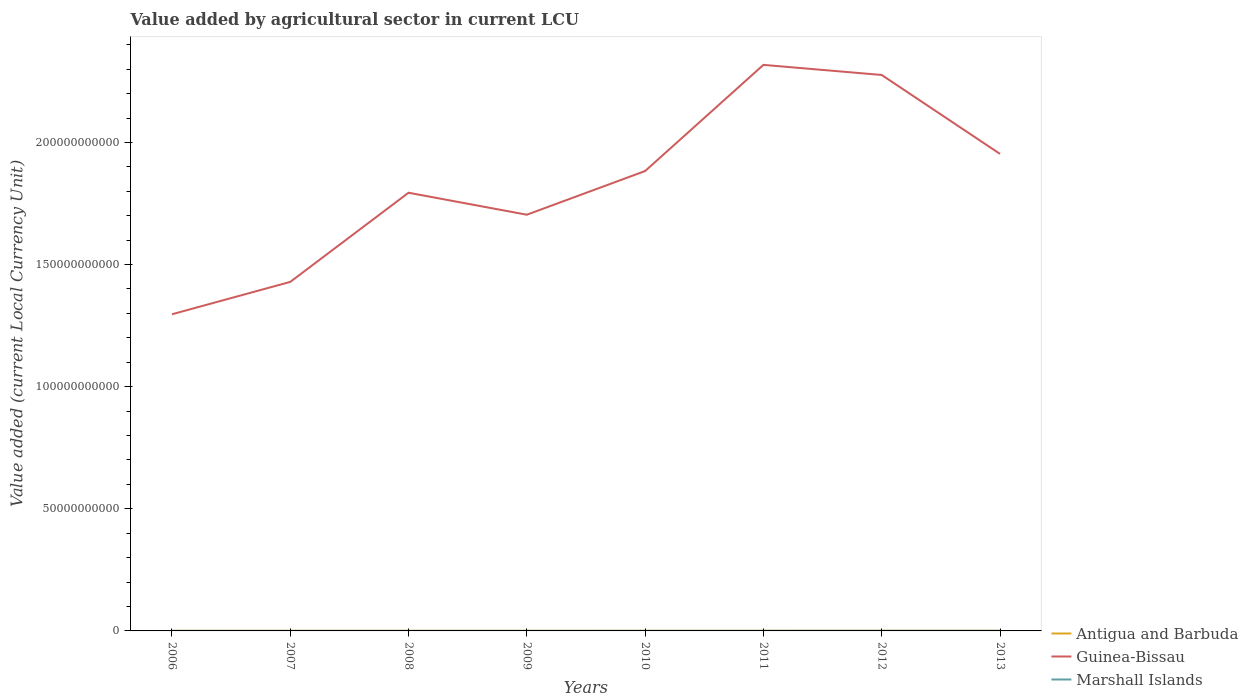Does the line corresponding to Guinea-Bissau intersect with the line corresponding to Marshall Islands?
Ensure brevity in your answer.  No. Is the number of lines equal to the number of legend labels?
Provide a short and direct response. Yes. Across all years, what is the maximum value added by agricultural sector in Antigua and Barbuda?
Your answer should be compact. 4.95e+07. In which year was the value added by agricultural sector in Antigua and Barbuda maximum?
Offer a very short reply. 2009. What is the total value added by agricultural sector in Guinea-Bissau in the graph?
Provide a succinct answer. 4.14e+09. What is the difference between the highest and the second highest value added by agricultural sector in Antigua and Barbuda?
Ensure brevity in your answer.  1.49e+07. How many lines are there?
Your response must be concise. 3. How many years are there in the graph?
Make the answer very short. 8. How are the legend labels stacked?
Provide a succinct answer. Vertical. What is the title of the graph?
Provide a short and direct response. Value added by agricultural sector in current LCU. Does "Liberia" appear as one of the legend labels in the graph?
Offer a very short reply. No. What is the label or title of the Y-axis?
Keep it short and to the point. Value added (current Local Currency Unit). What is the Value added (current Local Currency Unit) of Antigua and Barbuda in 2006?
Your answer should be compact. 5.16e+07. What is the Value added (current Local Currency Unit) in Guinea-Bissau in 2006?
Your response must be concise. 1.30e+11. What is the Value added (current Local Currency Unit) in Marshall Islands in 2006?
Provide a succinct answer. 1.22e+07. What is the Value added (current Local Currency Unit) in Antigua and Barbuda in 2007?
Offer a very short reply. 5.69e+07. What is the Value added (current Local Currency Unit) of Guinea-Bissau in 2007?
Provide a short and direct response. 1.43e+11. What is the Value added (current Local Currency Unit) in Marshall Islands in 2007?
Your response must be concise. 1.31e+07. What is the Value added (current Local Currency Unit) in Antigua and Barbuda in 2008?
Offer a terse response. 5.72e+07. What is the Value added (current Local Currency Unit) in Guinea-Bissau in 2008?
Offer a very short reply. 1.79e+11. What is the Value added (current Local Currency Unit) in Marshall Islands in 2008?
Your response must be concise. 1.54e+07. What is the Value added (current Local Currency Unit) of Antigua and Barbuda in 2009?
Offer a very short reply. 4.95e+07. What is the Value added (current Local Currency Unit) of Guinea-Bissau in 2009?
Your answer should be compact. 1.70e+11. What is the Value added (current Local Currency Unit) in Marshall Islands in 2009?
Your response must be concise. 1.87e+07. What is the Value added (current Local Currency Unit) in Antigua and Barbuda in 2010?
Your response must be concise. 5.06e+07. What is the Value added (current Local Currency Unit) in Guinea-Bissau in 2010?
Provide a succinct answer. 1.88e+11. What is the Value added (current Local Currency Unit) in Marshall Islands in 2010?
Make the answer very short. 2.42e+07. What is the Value added (current Local Currency Unit) of Antigua and Barbuda in 2011?
Offer a terse response. 5.94e+07. What is the Value added (current Local Currency Unit) of Guinea-Bissau in 2011?
Give a very brief answer. 2.32e+11. What is the Value added (current Local Currency Unit) in Marshall Islands in 2011?
Ensure brevity in your answer.  2.65e+07. What is the Value added (current Local Currency Unit) of Antigua and Barbuda in 2012?
Provide a short and direct response. 6.15e+07. What is the Value added (current Local Currency Unit) in Guinea-Bissau in 2012?
Provide a succinct answer. 2.28e+11. What is the Value added (current Local Currency Unit) of Marshall Islands in 2012?
Your answer should be compact. 3.96e+07. What is the Value added (current Local Currency Unit) of Antigua and Barbuda in 2013?
Give a very brief answer. 6.44e+07. What is the Value added (current Local Currency Unit) in Guinea-Bissau in 2013?
Your response must be concise. 1.95e+11. What is the Value added (current Local Currency Unit) of Marshall Islands in 2013?
Make the answer very short. 3.98e+07. Across all years, what is the maximum Value added (current Local Currency Unit) in Antigua and Barbuda?
Your answer should be compact. 6.44e+07. Across all years, what is the maximum Value added (current Local Currency Unit) in Guinea-Bissau?
Your response must be concise. 2.32e+11. Across all years, what is the maximum Value added (current Local Currency Unit) of Marshall Islands?
Ensure brevity in your answer.  3.98e+07. Across all years, what is the minimum Value added (current Local Currency Unit) of Antigua and Barbuda?
Your response must be concise. 4.95e+07. Across all years, what is the minimum Value added (current Local Currency Unit) of Guinea-Bissau?
Give a very brief answer. 1.30e+11. Across all years, what is the minimum Value added (current Local Currency Unit) of Marshall Islands?
Keep it short and to the point. 1.22e+07. What is the total Value added (current Local Currency Unit) in Antigua and Barbuda in the graph?
Your answer should be very brief. 4.51e+08. What is the total Value added (current Local Currency Unit) of Guinea-Bissau in the graph?
Keep it short and to the point. 1.47e+12. What is the total Value added (current Local Currency Unit) of Marshall Islands in the graph?
Your answer should be very brief. 1.89e+08. What is the difference between the Value added (current Local Currency Unit) in Antigua and Barbuda in 2006 and that in 2007?
Your response must be concise. -5.28e+06. What is the difference between the Value added (current Local Currency Unit) of Guinea-Bissau in 2006 and that in 2007?
Your answer should be very brief. -1.33e+1. What is the difference between the Value added (current Local Currency Unit) of Marshall Islands in 2006 and that in 2007?
Provide a succinct answer. -9.00e+05. What is the difference between the Value added (current Local Currency Unit) of Antigua and Barbuda in 2006 and that in 2008?
Your answer should be compact. -5.60e+06. What is the difference between the Value added (current Local Currency Unit) of Guinea-Bissau in 2006 and that in 2008?
Provide a short and direct response. -4.98e+1. What is the difference between the Value added (current Local Currency Unit) of Marshall Islands in 2006 and that in 2008?
Keep it short and to the point. -3.19e+06. What is the difference between the Value added (current Local Currency Unit) of Antigua and Barbuda in 2006 and that in 2009?
Offer a very short reply. 2.17e+06. What is the difference between the Value added (current Local Currency Unit) of Guinea-Bissau in 2006 and that in 2009?
Provide a succinct answer. -4.08e+1. What is the difference between the Value added (current Local Currency Unit) of Marshall Islands in 2006 and that in 2009?
Make the answer very short. -6.58e+06. What is the difference between the Value added (current Local Currency Unit) in Antigua and Barbuda in 2006 and that in 2010?
Provide a succinct answer. 9.98e+05. What is the difference between the Value added (current Local Currency Unit) in Guinea-Bissau in 2006 and that in 2010?
Offer a terse response. -5.86e+1. What is the difference between the Value added (current Local Currency Unit) of Marshall Islands in 2006 and that in 2010?
Offer a terse response. -1.20e+07. What is the difference between the Value added (current Local Currency Unit) in Antigua and Barbuda in 2006 and that in 2011?
Your response must be concise. -7.73e+06. What is the difference between the Value added (current Local Currency Unit) in Guinea-Bissau in 2006 and that in 2011?
Offer a very short reply. -1.02e+11. What is the difference between the Value added (current Local Currency Unit) in Marshall Islands in 2006 and that in 2011?
Your response must be concise. -1.43e+07. What is the difference between the Value added (current Local Currency Unit) in Antigua and Barbuda in 2006 and that in 2012?
Your answer should be compact. -9.88e+06. What is the difference between the Value added (current Local Currency Unit) in Guinea-Bissau in 2006 and that in 2012?
Give a very brief answer. -9.80e+1. What is the difference between the Value added (current Local Currency Unit) of Marshall Islands in 2006 and that in 2012?
Ensure brevity in your answer.  -2.74e+07. What is the difference between the Value added (current Local Currency Unit) in Antigua and Barbuda in 2006 and that in 2013?
Provide a succinct answer. -1.27e+07. What is the difference between the Value added (current Local Currency Unit) of Guinea-Bissau in 2006 and that in 2013?
Make the answer very short. -6.57e+1. What is the difference between the Value added (current Local Currency Unit) in Marshall Islands in 2006 and that in 2013?
Provide a succinct answer. -2.76e+07. What is the difference between the Value added (current Local Currency Unit) of Antigua and Barbuda in 2007 and that in 2008?
Your answer should be compact. -3.20e+05. What is the difference between the Value added (current Local Currency Unit) of Guinea-Bissau in 2007 and that in 2008?
Keep it short and to the point. -3.65e+1. What is the difference between the Value added (current Local Currency Unit) in Marshall Islands in 2007 and that in 2008?
Offer a very short reply. -2.29e+06. What is the difference between the Value added (current Local Currency Unit) of Antigua and Barbuda in 2007 and that in 2009?
Your answer should be compact. 7.45e+06. What is the difference between the Value added (current Local Currency Unit) in Guinea-Bissau in 2007 and that in 2009?
Make the answer very short. -2.75e+1. What is the difference between the Value added (current Local Currency Unit) in Marshall Islands in 2007 and that in 2009?
Make the answer very short. -5.68e+06. What is the difference between the Value added (current Local Currency Unit) in Antigua and Barbuda in 2007 and that in 2010?
Your answer should be compact. 6.28e+06. What is the difference between the Value added (current Local Currency Unit) of Guinea-Bissau in 2007 and that in 2010?
Make the answer very short. -4.54e+1. What is the difference between the Value added (current Local Currency Unit) of Marshall Islands in 2007 and that in 2010?
Offer a terse response. -1.11e+07. What is the difference between the Value added (current Local Currency Unit) of Antigua and Barbuda in 2007 and that in 2011?
Your response must be concise. -2.45e+06. What is the difference between the Value added (current Local Currency Unit) in Guinea-Bissau in 2007 and that in 2011?
Your answer should be very brief. -8.89e+1. What is the difference between the Value added (current Local Currency Unit) in Marshall Islands in 2007 and that in 2011?
Offer a terse response. -1.34e+07. What is the difference between the Value added (current Local Currency Unit) of Antigua and Barbuda in 2007 and that in 2012?
Your answer should be compact. -4.60e+06. What is the difference between the Value added (current Local Currency Unit) in Guinea-Bissau in 2007 and that in 2012?
Offer a terse response. -8.47e+1. What is the difference between the Value added (current Local Currency Unit) of Marshall Islands in 2007 and that in 2012?
Make the answer very short. -2.65e+07. What is the difference between the Value added (current Local Currency Unit) of Antigua and Barbuda in 2007 and that in 2013?
Make the answer very short. -7.43e+06. What is the difference between the Value added (current Local Currency Unit) of Guinea-Bissau in 2007 and that in 2013?
Keep it short and to the point. -5.24e+1. What is the difference between the Value added (current Local Currency Unit) of Marshall Islands in 2007 and that in 2013?
Offer a terse response. -2.67e+07. What is the difference between the Value added (current Local Currency Unit) in Antigua and Barbuda in 2008 and that in 2009?
Give a very brief answer. 7.77e+06. What is the difference between the Value added (current Local Currency Unit) in Guinea-Bissau in 2008 and that in 2009?
Offer a terse response. 9.00e+09. What is the difference between the Value added (current Local Currency Unit) in Marshall Islands in 2008 and that in 2009?
Give a very brief answer. -3.39e+06. What is the difference between the Value added (current Local Currency Unit) of Antigua and Barbuda in 2008 and that in 2010?
Offer a very short reply. 6.60e+06. What is the difference between the Value added (current Local Currency Unit) of Guinea-Bissau in 2008 and that in 2010?
Provide a succinct answer. -8.88e+09. What is the difference between the Value added (current Local Currency Unit) in Marshall Islands in 2008 and that in 2010?
Offer a very short reply. -8.84e+06. What is the difference between the Value added (current Local Currency Unit) of Antigua and Barbuda in 2008 and that in 2011?
Your answer should be compact. -2.13e+06. What is the difference between the Value added (current Local Currency Unit) of Guinea-Bissau in 2008 and that in 2011?
Give a very brief answer. -5.24e+1. What is the difference between the Value added (current Local Currency Unit) in Marshall Islands in 2008 and that in 2011?
Make the answer very short. -1.11e+07. What is the difference between the Value added (current Local Currency Unit) of Antigua and Barbuda in 2008 and that in 2012?
Your answer should be compact. -4.28e+06. What is the difference between the Value added (current Local Currency Unit) of Guinea-Bissau in 2008 and that in 2012?
Give a very brief answer. -4.82e+1. What is the difference between the Value added (current Local Currency Unit) of Marshall Islands in 2008 and that in 2012?
Give a very brief answer. -2.42e+07. What is the difference between the Value added (current Local Currency Unit) in Antigua and Barbuda in 2008 and that in 2013?
Give a very brief answer. -7.11e+06. What is the difference between the Value added (current Local Currency Unit) in Guinea-Bissau in 2008 and that in 2013?
Ensure brevity in your answer.  -1.59e+1. What is the difference between the Value added (current Local Currency Unit) of Marshall Islands in 2008 and that in 2013?
Provide a short and direct response. -2.44e+07. What is the difference between the Value added (current Local Currency Unit) of Antigua and Barbuda in 2009 and that in 2010?
Make the answer very short. -1.17e+06. What is the difference between the Value added (current Local Currency Unit) of Guinea-Bissau in 2009 and that in 2010?
Your answer should be compact. -1.79e+1. What is the difference between the Value added (current Local Currency Unit) in Marshall Islands in 2009 and that in 2010?
Your response must be concise. -5.46e+06. What is the difference between the Value added (current Local Currency Unit) in Antigua and Barbuda in 2009 and that in 2011?
Your response must be concise. -9.90e+06. What is the difference between the Value added (current Local Currency Unit) in Guinea-Bissau in 2009 and that in 2011?
Ensure brevity in your answer.  -6.14e+1. What is the difference between the Value added (current Local Currency Unit) in Marshall Islands in 2009 and that in 2011?
Your answer should be very brief. -7.71e+06. What is the difference between the Value added (current Local Currency Unit) of Antigua and Barbuda in 2009 and that in 2012?
Your answer should be compact. -1.20e+07. What is the difference between the Value added (current Local Currency Unit) in Guinea-Bissau in 2009 and that in 2012?
Offer a very short reply. -5.72e+1. What is the difference between the Value added (current Local Currency Unit) in Marshall Islands in 2009 and that in 2012?
Your answer should be very brief. -2.08e+07. What is the difference between the Value added (current Local Currency Unit) of Antigua and Barbuda in 2009 and that in 2013?
Offer a very short reply. -1.49e+07. What is the difference between the Value added (current Local Currency Unit) of Guinea-Bissau in 2009 and that in 2013?
Ensure brevity in your answer.  -2.49e+1. What is the difference between the Value added (current Local Currency Unit) in Marshall Islands in 2009 and that in 2013?
Your answer should be very brief. -2.10e+07. What is the difference between the Value added (current Local Currency Unit) of Antigua and Barbuda in 2010 and that in 2011?
Provide a succinct answer. -8.73e+06. What is the difference between the Value added (current Local Currency Unit) of Guinea-Bissau in 2010 and that in 2011?
Offer a very short reply. -4.35e+1. What is the difference between the Value added (current Local Currency Unit) of Marshall Islands in 2010 and that in 2011?
Your response must be concise. -2.25e+06. What is the difference between the Value added (current Local Currency Unit) of Antigua and Barbuda in 2010 and that in 2012?
Your answer should be compact. -1.09e+07. What is the difference between the Value added (current Local Currency Unit) in Guinea-Bissau in 2010 and that in 2012?
Ensure brevity in your answer.  -3.93e+1. What is the difference between the Value added (current Local Currency Unit) of Marshall Islands in 2010 and that in 2012?
Offer a very short reply. -1.54e+07. What is the difference between the Value added (current Local Currency Unit) of Antigua and Barbuda in 2010 and that in 2013?
Make the answer very short. -1.37e+07. What is the difference between the Value added (current Local Currency Unit) in Guinea-Bissau in 2010 and that in 2013?
Provide a succinct answer. -7.02e+09. What is the difference between the Value added (current Local Currency Unit) in Marshall Islands in 2010 and that in 2013?
Provide a short and direct response. -1.56e+07. What is the difference between the Value added (current Local Currency Unit) in Antigua and Barbuda in 2011 and that in 2012?
Make the answer very short. -2.15e+06. What is the difference between the Value added (current Local Currency Unit) of Guinea-Bissau in 2011 and that in 2012?
Offer a very short reply. 4.14e+09. What is the difference between the Value added (current Local Currency Unit) in Marshall Islands in 2011 and that in 2012?
Keep it short and to the point. -1.31e+07. What is the difference between the Value added (current Local Currency Unit) in Antigua and Barbuda in 2011 and that in 2013?
Offer a very short reply. -4.98e+06. What is the difference between the Value added (current Local Currency Unit) of Guinea-Bissau in 2011 and that in 2013?
Your answer should be compact. 3.64e+1. What is the difference between the Value added (current Local Currency Unit) in Marshall Islands in 2011 and that in 2013?
Offer a terse response. -1.33e+07. What is the difference between the Value added (current Local Currency Unit) in Antigua and Barbuda in 2012 and that in 2013?
Offer a very short reply. -2.83e+06. What is the difference between the Value added (current Local Currency Unit) in Guinea-Bissau in 2012 and that in 2013?
Offer a terse response. 3.23e+1. What is the difference between the Value added (current Local Currency Unit) in Marshall Islands in 2012 and that in 2013?
Keep it short and to the point. -2.11e+05. What is the difference between the Value added (current Local Currency Unit) of Antigua and Barbuda in 2006 and the Value added (current Local Currency Unit) of Guinea-Bissau in 2007?
Provide a short and direct response. -1.43e+11. What is the difference between the Value added (current Local Currency Unit) in Antigua and Barbuda in 2006 and the Value added (current Local Currency Unit) in Marshall Islands in 2007?
Keep it short and to the point. 3.86e+07. What is the difference between the Value added (current Local Currency Unit) in Guinea-Bissau in 2006 and the Value added (current Local Currency Unit) in Marshall Islands in 2007?
Make the answer very short. 1.30e+11. What is the difference between the Value added (current Local Currency Unit) of Antigua and Barbuda in 2006 and the Value added (current Local Currency Unit) of Guinea-Bissau in 2008?
Make the answer very short. -1.79e+11. What is the difference between the Value added (current Local Currency Unit) of Antigua and Barbuda in 2006 and the Value added (current Local Currency Unit) of Marshall Islands in 2008?
Offer a very short reply. 3.63e+07. What is the difference between the Value added (current Local Currency Unit) in Guinea-Bissau in 2006 and the Value added (current Local Currency Unit) in Marshall Islands in 2008?
Provide a succinct answer. 1.30e+11. What is the difference between the Value added (current Local Currency Unit) of Antigua and Barbuda in 2006 and the Value added (current Local Currency Unit) of Guinea-Bissau in 2009?
Offer a terse response. -1.70e+11. What is the difference between the Value added (current Local Currency Unit) of Antigua and Barbuda in 2006 and the Value added (current Local Currency Unit) of Marshall Islands in 2009?
Your answer should be compact. 3.29e+07. What is the difference between the Value added (current Local Currency Unit) in Guinea-Bissau in 2006 and the Value added (current Local Currency Unit) in Marshall Islands in 2009?
Provide a short and direct response. 1.30e+11. What is the difference between the Value added (current Local Currency Unit) in Antigua and Barbuda in 2006 and the Value added (current Local Currency Unit) in Guinea-Bissau in 2010?
Your answer should be very brief. -1.88e+11. What is the difference between the Value added (current Local Currency Unit) of Antigua and Barbuda in 2006 and the Value added (current Local Currency Unit) of Marshall Islands in 2010?
Your response must be concise. 2.74e+07. What is the difference between the Value added (current Local Currency Unit) in Guinea-Bissau in 2006 and the Value added (current Local Currency Unit) in Marshall Islands in 2010?
Your response must be concise. 1.30e+11. What is the difference between the Value added (current Local Currency Unit) in Antigua and Barbuda in 2006 and the Value added (current Local Currency Unit) in Guinea-Bissau in 2011?
Provide a succinct answer. -2.32e+11. What is the difference between the Value added (current Local Currency Unit) of Antigua and Barbuda in 2006 and the Value added (current Local Currency Unit) of Marshall Islands in 2011?
Your answer should be compact. 2.52e+07. What is the difference between the Value added (current Local Currency Unit) in Guinea-Bissau in 2006 and the Value added (current Local Currency Unit) in Marshall Islands in 2011?
Give a very brief answer. 1.30e+11. What is the difference between the Value added (current Local Currency Unit) in Antigua and Barbuda in 2006 and the Value added (current Local Currency Unit) in Guinea-Bissau in 2012?
Ensure brevity in your answer.  -2.28e+11. What is the difference between the Value added (current Local Currency Unit) of Antigua and Barbuda in 2006 and the Value added (current Local Currency Unit) of Marshall Islands in 2012?
Provide a succinct answer. 1.21e+07. What is the difference between the Value added (current Local Currency Unit) of Guinea-Bissau in 2006 and the Value added (current Local Currency Unit) of Marshall Islands in 2012?
Offer a very short reply. 1.30e+11. What is the difference between the Value added (current Local Currency Unit) of Antigua and Barbuda in 2006 and the Value added (current Local Currency Unit) of Guinea-Bissau in 2013?
Provide a short and direct response. -1.95e+11. What is the difference between the Value added (current Local Currency Unit) in Antigua and Barbuda in 2006 and the Value added (current Local Currency Unit) in Marshall Islands in 2013?
Give a very brief answer. 1.19e+07. What is the difference between the Value added (current Local Currency Unit) of Guinea-Bissau in 2006 and the Value added (current Local Currency Unit) of Marshall Islands in 2013?
Your answer should be very brief. 1.30e+11. What is the difference between the Value added (current Local Currency Unit) of Antigua and Barbuda in 2007 and the Value added (current Local Currency Unit) of Guinea-Bissau in 2008?
Offer a terse response. -1.79e+11. What is the difference between the Value added (current Local Currency Unit) in Antigua and Barbuda in 2007 and the Value added (current Local Currency Unit) in Marshall Islands in 2008?
Ensure brevity in your answer.  4.16e+07. What is the difference between the Value added (current Local Currency Unit) of Guinea-Bissau in 2007 and the Value added (current Local Currency Unit) of Marshall Islands in 2008?
Make the answer very short. 1.43e+11. What is the difference between the Value added (current Local Currency Unit) of Antigua and Barbuda in 2007 and the Value added (current Local Currency Unit) of Guinea-Bissau in 2009?
Offer a terse response. -1.70e+11. What is the difference between the Value added (current Local Currency Unit) of Antigua and Barbuda in 2007 and the Value added (current Local Currency Unit) of Marshall Islands in 2009?
Ensure brevity in your answer.  3.82e+07. What is the difference between the Value added (current Local Currency Unit) in Guinea-Bissau in 2007 and the Value added (current Local Currency Unit) in Marshall Islands in 2009?
Your answer should be very brief. 1.43e+11. What is the difference between the Value added (current Local Currency Unit) in Antigua and Barbuda in 2007 and the Value added (current Local Currency Unit) in Guinea-Bissau in 2010?
Offer a very short reply. -1.88e+11. What is the difference between the Value added (current Local Currency Unit) of Antigua and Barbuda in 2007 and the Value added (current Local Currency Unit) of Marshall Islands in 2010?
Offer a very short reply. 3.27e+07. What is the difference between the Value added (current Local Currency Unit) in Guinea-Bissau in 2007 and the Value added (current Local Currency Unit) in Marshall Islands in 2010?
Give a very brief answer. 1.43e+11. What is the difference between the Value added (current Local Currency Unit) of Antigua and Barbuda in 2007 and the Value added (current Local Currency Unit) of Guinea-Bissau in 2011?
Ensure brevity in your answer.  -2.32e+11. What is the difference between the Value added (current Local Currency Unit) in Antigua and Barbuda in 2007 and the Value added (current Local Currency Unit) in Marshall Islands in 2011?
Your answer should be compact. 3.05e+07. What is the difference between the Value added (current Local Currency Unit) in Guinea-Bissau in 2007 and the Value added (current Local Currency Unit) in Marshall Islands in 2011?
Make the answer very short. 1.43e+11. What is the difference between the Value added (current Local Currency Unit) of Antigua and Barbuda in 2007 and the Value added (current Local Currency Unit) of Guinea-Bissau in 2012?
Provide a succinct answer. -2.28e+11. What is the difference between the Value added (current Local Currency Unit) in Antigua and Barbuda in 2007 and the Value added (current Local Currency Unit) in Marshall Islands in 2012?
Give a very brief answer. 1.73e+07. What is the difference between the Value added (current Local Currency Unit) of Guinea-Bissau in 2007 and the Value added (current Local Currency Unit) of Marshall Islands in 2012?
Ensure brevity in your answer.  1.43e+11. What is the difference between the Value added (current Local Currency Unit) of Antigua and Barbuda in 2007 and the Value added (current Local Currency Unit) of Guinea-Bissau in 2013?
Offer a terse response. -1.95e+11. What is the difference between the Value added (current Local Currency Unit) in Antigua and Barbuda in 2007 and the Value added (current Local Currency Unit) in Marshall Islands in 2013?
Ensure brevity in your answer.  1.71e+07. What is the difference between the Value added (current Local Currency Unit) in Guinea-Bissau in 2007 and the Value added (current Local Currency Unit) in Marshall Islands in 2013?
Provide a short and direct response. 1.43e+11. What is the difference between the Value added (current Local Currency Unit) in Antigua and Barbuda in 2008 and the Value added (current Local Currency Unit) in Guinea-Bissau in 2009?
Provide a short and direct response. -1.70e+11. What is the difference between the Value added (current Local Currency Unit) in Antigua and Barbuda in 2008 and the Value added (current Local Currency Unit) in Marshall Islands in 2009?
Provide a short and direct response. 3.85e+07. What is the difference between the Value added (current Local Currency Unit) in Guinea-Bissau in 2008 and the Value added (current Local Currency Unit) in Marshall Islands in 2009?
Offer a terse response. 1.79e+11. What is the difference between the Value added (current Local Currency Unit) of Antigua and Barbuda in 2008 and the Value added (current Local Currency Unit) of Guinea-Bissau in 2010?
Ensure brevity in your answer.  -1.88e+11. What is the difference between the Value added (current Local Currency Unit) of Antigua and Barbuda in 2008 and the Value added (current Local Currency Unit) of Marshall Islands in 2010?
Make the answer very short. 3.30e+07. What is the difference between the Value added (current Local Currency Unit) in Guinea-Bissau in 2008 and the Value added (current Local Currency Unit) in Marshall Islands in 2010?
Keep it short and to the point. 1.79e+11. What is the difference between the Value added (current Local Currency Unit) of Antigua and Barbuda in 2008 and the Value added (current Local Currency Unit) of Guinea-Bissau in 2011?
Offer a terse response. -2.32e+11. What is the difference between the Value added (current Local Currency Unit) in Antigua and Barbuda in 2008 and the Value added (current Local Currency Unit) in Marshall Islands in 2011?
Give a very brief answer. 3.08e+07. What is the difference between the Value added (current Local Currency Unit) in Guinea-Bissau in 2008 and the Value added (current Local Currency Unit) in Marshall Islands in 2011?
Make the answer very short. 1.79e+11. What is the difference between the Value added (current Local Currency Unit) in Antigua and Barbuda in 2008 and the Value added (current Local Currency Unit) in Guinea-Bissau in 2012?
Your answer should be compact. -2.28e+11. What is the difference between the Value added (current Local Currency Unit) in Antigua and Barbuda in 2008 and the Value added (current Local Currency Unit) in Marshall Islands in 2012?
Provide a succinct answer. 1.77e+07. What is the difference between the Value added (current Local Currency Unit) in Guinea-Bissau in 2008 and the Value added (current Local Currency Unit) in Marshall Islands in 2012?
Ensure brevity in your answer.  1.79e+11. What is the difference between the Value added (current Local Currency Unit) in Antigua and Barbuda in 2008 and the Value added (current Local Currency Unit) in Guinea-Bissau in 2013?
Make the answer very short. -1.95e+11. What is the difference between the Value added (current Local Currency Unit) in Antigua and Barbuda in 2008 and the Value added (current Local Currency Unit) in Marshall Islands in 2013?
Make the answer very short. 1.75e+07. What is the difference between the Value added (current Local Currency Unit) of Guinea-Bissau in 2008 and the Value added (current Local Currency Unit) of Marshall Islands in 2013?
Ensure brevity in your answer.  1.79e+11. What is the difference between the Value added (current Local Currency Unit) in Antigua and Barbuda in 2009 and the Value added (current Local Currency Unit) in Guinea-Bissau in 2010?
Make the answer very short. -1.88e+11. What is the difference between the Value added (current Local Currency Unit) in Antigua and Barbuda in 2009 and the Value added (current Local Currency Unit) in Marshall Islands in 2010?
Provide a short and direct response. 2.53e+07. What is the difference between the Value added (current Local Currency Unit) in Guinea-Bissau in 2009 and the Value added (current Local Currency Unit) in Marshall Islands in 2010?
Give a very brief answer. 1.70e+11. What is the difference between the Value added (current Local Currency Unit) of Antigua and Barbuda in 2009 and the Value added (current Local Currency Unit) of Guinea-Bissau in 2011?
Keep it short and to the point. -2.32e+11. What is the difference between the Value added (current Local Currency Unit) in Antigua and Barbuda in 2009 and the Value added (current Local Currency Unit) in Marshall Islands in 2011?
Provide a succinct answer. 2.30e+07. What is the difference between the Value added (current Local Currency Unit) in Guinea-Bissau in 2009 and the Value added (current Local Currency Unit) in Marshall Islands in 2011?
Offer a terse response. 1.70e+11. What is the difference between the Value added (current Local Currency Unit) in Antigua and Barbuda in 2009 and the Value added (current Local Currency Unit) in Guinea-Bissau in 2012?
Keep it short and to the point. -2.28e+11. What is the difference between the Value added (current Local Currency Unit) of Antigua and Barbuda in 2009 and the Value added (current Local Currency Unit) of Marshall Islands in 2012?
Ensure brevity in your answer.  9.89e+06. What is the difference between the Value added (current Local Currency Unit) in Guinea-Bissau in 2009 and the Value added (current Local Currency Unit) in Marshall Islands in 2012?
Give a very brief answer. 1.70e+11. What is the difference between the Value added (current Local Currency Unit) of Antigua and Barbuda in 2009 and the Value added (current Local Currency Unit) of Guinea-Bissau in 2013?
Provide a short and direct response. -1.95e+11. What is the difference between the Value added (current Local Currency Unit) in Antigua and Barbuda in 2009 and the Value added (current Local Currency Unit) in Marshall Islands in 2013?
Make the answer very short. 9.68e+06. What is the difference between the Value added (current Local Currency Unit) of Guinea-Bissau in 2009 and the Value added (current Local Currency Unit) of Marshall Islands in 2013?
Keep it short and to the point. 1.70e+11. What is the difference between the Value added (current Local Currency Unit) of Antigua and Barbuda in 2010 and the Value added (current Local Currency Unit) of Guinea-Bissau in 2011?
Provide a short and direct response. -2.32e+11. What is the difference between the Value added (current Local Currency Unit) in Antigua and Barbuda in 2010 and the Value added (current Local Currency Unit) in Marshall Islands in 2011?
Your answer should be very brief. 2.42e+07. What is the difference between the Value added (current Local Currency Unit) in Guinea-Bissau in 2010 and the Value added (current Local Currency Unit) in Marshall Islands in 2011?
Offer a terse response. 1.88e+11. What is the difference between the Value added (current Local Currency Unit) of Antigua and Barbuda in 2010 and the Value added (current Local Currency Unit) of Guinea-Bissau in 2012?
Provide a succinct answer. -2.28e+11. What is the difference between the Value added (current Local Currency Unit) of Antigua and Barbuda in 2010 and the Value added (current Local Currency Unit) of Marshall Islands in 2012?
Make the answer very short. 1.11e+07. What is the difference between the Value added (current Local Currency Unit) in Guinea-Bissau in 2010 and the Value added (current Local Currency Unit) in Marshall Islands in 2012?
Keep it short and to the point. 1.88e+11. What is the difference between the Value added (current Local Currency Unit) of Antigua and Barbuda in 2010 and the Value added (current Local Currency Unit) of Guinea-Bissau in 2013?
Your answer should be very brief. -1.95e+11. What is the difference between the Value added (current Local Currency Unit) of Antigua and Barbuda in 2010 and the Value added (current Local Currency Unit) of Marshall Islands in 2013?
Provide a short and direct response. 1.09e+07. What is the difference between the Value added (current Local Currency Unit) in Guinea-Bissau in 2010 and the Value added (current Local Currency Unit) in Marshall Islands in 2013?
Keep it short and to the point. 1.88e+11. What is the difference between the Value added (current Local Currency Unit) of Antigua and Barbuda in 2011 and the Value added (current Local Currency Unit) of Guinea-Bissau in 2012?
Give a very brief answer. -2.28e+11. What is the difference between the Value added (current Local Currency Unit) in Antigua and Barbuda in 2011 and the Value added (current Local Currency Unit) in Marshall Islands in 2012?
Ensure brevity in your answer.  1.98e+07. What is the difference between the Value added (current Local Currency Unit) in Guinea-Bissau in 2011 and the Value added (current Local Currency Unit) in Marshall Islands in 2012?
Keep it short and to the point. 2.32e+11. What is the difference between the Value added (current Local Currency Unit) of Antigua and Barbuda in 2011 and the Value added (current Local Currency Unit) of Guinea-Bissau in 2013?
Keep it short and to the point. -1.95e+11. What is the difference between the Value added (current Local Currency Unit) in Antigua and Barbuda in 2011 and the Value added (current Local Currency Unit) in Marshall Islands in 2013?
Offer a terse response. 1.96e+07. What is the difference between the Value added (current Local Currency Unit) in Guinea-Bissau in 2011 and the Value added (current Local Currency Unit) in Marshall Islands in 2013?
Make the answer very short. 2.32e+11. What is the difference between the Value added (current Local Currency Unit) in Antigua and Barbuda in 2012 and the Value added (current Local Currency Unit) in Guinea-Bissau in 2013?
Your answer should be compact. -1.95e+11. What is the difference between the Value added (current Local Currency Unit) of Antigua and Barbuda in 2012 and the Value added (current Local Currency Unit) of Marshall Islands in 2013?
Your answer should be compact. 2.17e+07. What is the difference between the Value added (current Local Currency Unit) of Guinea-Bissau in 2012 and the Value added (current Local Currency Unit) of Marshall Islands in 2013?
Keep it short and to the point. 2.28e+11. What is the average Value added (current Local Currency Unit) of Antigua and Barbuda per year?
Make the answer very short. 5.64e+07. What is the average Value added (current Local Currency Unit) of Guinea-Bissau per year?
Provide a short and direct response. 1.83e+11. What is the average Value added (current Local Currency Unit) in Marshall Islands per year?
Your answer should be very brief. 2.37e+07. In the year 2006, what is the difference between the Value added (current Local Currency Unit) of Antigua and Barbuda and Value added (current Local Currency Unit) of Guinea-Bissau?
Give a very brief answer. -1.30e+11. In the year 2006, what is the difference between the Value added (current Local Currency Unit) in Antigua and Barbuda and Value added (current Local Currency Unit) in Marshall Islands?
Ensure brevity in your answer.  3.95e+07. In the year 2006, what is the difference between the Value added (current Local Currency Unit) of Guinea-Bissau and Value added (current Local Currency Unit) of Marshall Islands?
Offer a terse response. 1.30e+11. In the year 2007, what is the difference between the Value added (current Local Currency Unit) in Antigua and Barbuda and Value added (current Local Currency Unit) in Guinea-Bissau?
Give a very brief answer. -1.43e+11. In the year 2007, what is the difference between the Value added (current Local Currency Unit) of Antigua and Barbuda and Value added (current Local Currency Unit) of Marshall Islands?
Your response must be concise. 4.39e+07. In the year 2007, what is the difference between the Value added (current Local Currency Unit) in Guinea-Bissau and Value added (current Local Currency Unit) in Marshall Islands?
Your answer should be compact. 1.43e+11. In the year 2008, what is the difference between the Value added (current Local Currency Unit) of Antigua and Barbuda and Value added (current Local Currency Unit) of Guinea-Bissau?
Offer a very short reply. -1.79e+11. In the year 2008, what is the difference between the Value added (current Local Currency Unit) in Antigua and Barbuda and Value added (current Local Currency Unit) in Marshall Islands?
Provide a short and direct response. 4.19e+07. In the year 2008, what is the difference between the Value added (current Local Currency Unit) in Guinea-Bissau and Value added (current Local Currency Unit) in Marshall Islands?
Give a very brief answer. 1.79e+11. In the year 2009, what is the difference between the Value added (current Local Currency Unit) in Antigua and Barbuda and Value added (current Local Currency Unit) in Guinea-Bissau?
Make the answer very short. -1.70e+11. In the year 2009, what is the difference between the Value added (current Local Currency Unit) of Antigua and Barbuda and Value added (current Local Currency Unit) of Marshall Islands?
Your answer should be compact. 3.07e+07. In the year 2009, what is the difference between the Value added (current Local Currency Unit) of Guinea-Bissau and Value added (current Local Currency Unit) of Marshall Islands?
Ensure brevity in your answer.  1.70e+11. In the year 2010, what is the difference between the Value added (current Local Currency Unit) in Antigua and Barbuda and Value added (current Local Currency Unit) in Guinea-Bissau?
Offer a terse response. -1.88e+11. In the year 2010, what is the difference between the Value added (current Local Currency Unit) of Antigua and Barbuda and Value added (current Local Currency Unit) of Marshall Islands?
Your answer should be very brief. 2.64e+07. In the year 2010, what is the difference between the Value added (current Local Currency Unit) in Guinea-Bissau and Value added (current Local Currency Unit) in Marshall Islands?
Make the answer very short. 1.88e+11. In the year 2011, what is the difference between the Value added (current Local Currency Unit) in Antigua and Barbuda and Value added (current Local Currency Unit) in Guinea-Bissau?
Your response must be concise. -2.32e+11. In the year 2011, what is the difference between the Value added (current Local Currency Unit) of Antigua and Barbuda and Value added (current Local Currency Unit) of Marshall Islands?
Offer a very short reply. 3.29e+07. In the year 2011, what is the difference between the Value added (current Local Currency Unit) of Guinea-Bissau and Value added (current Local Currency Unit) of Marshall Islands?
Keep it short and to the point. 2.32e+11. In the year 2012, what is the difference between the Value added (current Local Currency Unit) in Antigua and Barbuda and Value added (current Local Currency Unit) in Guinea-Bissau?
Your answer should be compact. -2.28e+11. In the year 2012, what is the difference between the Value added (current Local Currency Unit) of Antigua and Barbuda and Value added (current Local Currency Unit) of Marshall Islands?
Your response must be concise. 2.19e+07. In the year 2012, what is the difference between the Value added (current Local Currency Unit) in Guinea-Bissau and Value added (current Local Currency Unit) in Marshall Islands?
Your answer should be compact. 2.28e+11. In the year 2013, what is the difference between the Value added (current Local Currency Unit) of Antigua and Barbuda and Value added (current Local Currency Unit) of Guinea-Bissau?
Offer a very short reply. -1.95e+11. In the year 2013, what is the difference between the Value added (current Local Currency Unit) of Antigua and Barbuda and Value added (current Local Currency Unit) of Marshall Islands?
Give a very brief answer. 2.46e+07. In the year 2013, what is the difference between the Value added (current Local Currency Unit) of Guinea-Bissau and Value added (current Local Currency Unit) of Marshall Islands?
Provide a succinct answer. 1.95e+11. What is the ratio of the Value added (current Local Currency Unit) of Antigua and Barbuda in 2006 to that in 2007?
Make the answer very short. 0.91. What is the ratio of the Value added (current Local Currency Unit) of Guinea-Bissau in 2006 to that in 2007?
Your answer should be very brief. 0.91. What is the ratio of the Value added (current Local Currency Unit) in Marshall Islands in 2006 to that in 2007?
Keep it short and to the point. 0.93. What is the ratio of the Value added (current Local Currency Unit) in Antigua and Barbuda in 2006 to that in 2008?
Your answer should be compact. 0.9. What is the ratio of the Value added (current Local Currency Unit) of Guinea-Bissau in 2006 to that in 2008?
Provide a short and direct response. 0.72. What is the ratio of the Value added (current Local Currency Unit) in Marshall Islands in 2006 to that in 2008?
Keep it short and to the point. 0.79. What is the ratio of the Value added (current Local Currency Unit) in Antigua and Barbuda in 2006 to that in 2009?
Keep it short and to the point. 1.04. What is the ratio of the Value added (current Local Currency Unit) of Guinea-Bissau in 2006 to that in 2009?
Offer a very short reply. 0.76. What is the ratio of the Value added (current Local Currency Unit) of Marshall Islands in 2006 to that in 2009?
Your response must be concise. 0.65. What is the ratio of the Value added (current Local Currency Unit) in Antigua and Barbuda in 2006 to that in 2010?
Your answer should be very brief. 1.02. What is the ratio of the Value added (current Local Currency Unit) in Guinea-Bissau in 2006 to that in 2010?
Ensure brevity in your answer.  0.69. What is the ratio of the Value added (current Local Currency Unit) in Marshall Islands in 2006 to that in 2010?
Keep it short and to the point. 0.5. What is the ratio of the Value added (current Local Currency Unit) in Antigua and Barbuda in 2006 to that in 2011?
Provide a short and direct response. 0.87. What is the ratio of the Value added (current Local Currency Unit) of Guinea-Bissau in 2006 to that in 2011?
Give a very brief answer. 0.56. What is the ratio of the Value added (current Local Currency Unit) in Marshall Islands in 2006 to that in 2011?
Your response must be concise. 0.46. What is the ratio of the Value added (current Local Currency Unit) in Antigua and Barbuda in 2006 to that in 2012?
Keep it short and to the point. 0.84. What is the ratio of the Value added (current Local Currency Unit) of Guinea-Bissau in 2006 to that in 2012?
Give a very brief answer. 0.57. What is the ratio of the Value added (current Local Currency Unit) in Marshall Islands in 2006 to that in 2012?
Your answer should be compact. 0.31. What is the ratio of the Value added (current Local Currency Unit) of Antigua and Barbuda in 2006 to that in 2013?
Offer a very short reply. 0.8. What is the ratio of the Value added (current Local Currency Unit) of Guinea-Bissau in 2006 to that in 2013?
Your response must be concise. 0.66. What is the ratio of the Value added (current Local Currency Unit) in Marshall Islands in 2006 to that in 2013?
Keep it short and to the point. 0.31. What is the ratio of the Value added (current Local Currency Unit) in Antigua and Barbuda in 2007 to that in 2008?
Make the answer very short. 0.99. What is the ratio of the Value added (current Local Currency Unit) of Guinea-Bissau in 2007 to that in 2008?
Your response must be concise. 0.8. What is the ratio of the Value added (current Local Currency Unit) of Marshall Islands in 2007 to that in 2008?
Make the answer very short. 0.85. What is the ratio of the Value added (current Local Currency Unit) of Antigua and Barbuda in 2007 to that in 2009?
Provide a short and direct response. 1.15. What is the ratio of the Value added (current Local Currency Unit) of Guinea-Bissau in 2007 to that in 2009?
Keep it short and to the point. 0.84. What is the ratio of the Value added (current Local Currency Unit) in Marshall Islands in 2007 to that in 2009?
Provide a succinct answer. 0.7. What is the ratio of the Value added (current Local Currency Unit) of Antigua and Barbuda in 2007 to that in 2010?
Offer a terse response. 1.12. What is the ratio of the Value added (current Local Currency Unit) of Guinea-Bissau in 2007 to that in 2010?
Offer a very short reply. 0.76. What is the ratio of the Value added (current Local Currency Unit) in Marshall Islands in 2007 to that in 2010?
Your answer should be very brief. 0.54. What is the ratio of the Value added (current Local Currency Unit) of Antigua and Barbuda in 2007 to that in 2011?
Your answer should be compact. 0.96. What is the ratio of the Value added (current Local Currency Unit) of Guinea-Bissau in 2007 to that in 2011?
Offer a terse response. 0.62. What is the ratio of the Value added (current Local Currency Unit) of Marshall Islands in 2007 to that in 2011?
Provide a succinct answer. 0.49. What is the ratio of the Value added (current Local Currency Unit) of Antigua and Barbuda in 2007 to that in 2012?
Provide a short and direct response. 0.93. What is the ratio of the Value added (current Local Currency Unit) of Guinea-Bissau in 2007 to that in 2012?
Ensure brevity in your answer.  0.63. What is the ratio of the Value added (current Local Currency Unit) of Marshall Islands in 2007 to that in 2012?
Your answer should be compact. 0.33. What is the ratio of the Value added (current Local Currency Unit) in Antigua and Barbuda in 2007 to that in 2013?
Offer a very short reply. 0.88. What is the ratio of the Value added (current Local Currency Unit) in Guinea-Bissau in 2007 to that in 2013?
Provide a short and direct response. 0.73. What is the ratio of the Value added (current Local Currency Unit) of Marshall Islands in 2007 to that in 2013?
Make the answer very short. 0.33. What is the ratio of the Value added (current Local Currency Unit) in Antigua and Barbuda in 2008 to that in 2009?
Offer a very short reply. 1.16. What is the ratio of the Value added (current Local Currency Unit) of Guinea-Bissau in 2008 to that in 2009?
Make the answer very short. 1.05. What is the ratio of the Value added (current Local Currency Unit) of Marshall Islands in 2008 to that in 2009?
Your answer should be compact. 0.82. What is the ratio of the Value added (current Local Currency Unit) in Antigua and Barbuda in 2008 to that in 2010?
Make the answer very short. 1.13. What is the ratio of the Value added (current Local Currency Unit) of Guinea-Bissau in 2008 to that in 2010?
Offer a terse response. 0.95. What is the ratio of the Value added (current Local Currency Unit) of Marshall Islands in 2008 to that in 2010?
Keep it short and to the point. 0.63. What is the ratio of the Value added (current Local Currency Unit) in Antigua and Barbuda in 2008 to that in 2011?
Give a very brief answer. 0.96. What is the ratio of the Value added (current Local Currency Unit) of Guinea-Bissau in 2008 to that in 2011?
Offer a very short reply. 0.77. What is the ratio of the Value added (current Local Currency Unit) in Marshall Islands in 2008 to that in 2011?
Make the answer very short. 0.58. What is the ratio of the Value added (current Local Currency Unit) in Antigua and Barbuda in 2008 to that in 2012?
Ensure brevity in your answer.  0.93. What is the ratio of the Value added (current Local Currency Unit) of Guinea-Bissau in 2008 to that in 2012?
Your response must be concise. 0.79. What is the ratio of the Value added (current Local Currency Unit) of Marshall Islands in 2008 to that in 2012?
Offer a terse response. 0.39. What is the ratio of the Value added (current Local Currency Unit) in Antigua and Barbuda in 2008 to that in 2013?
Give a very brief answer. 0.89. What is the ratio of the Value added (current Local Currency Unit) of Guinea-Bissau in 2008 to that in 2013?
Provide a succinct answer. 0.92. What is the ratio of the Value added (current Local Currency Unit) in Marshall Islands in 2008 to that in 2013?
Offer a terse response. 0.39. What is the ratio of the Value added (current Local Currency Unit) in Antigua and Barbuda in 2009 to that in 2010?
Provide a succinct answer. 0.98. What is the ratio of the Value added (current Local Currency Unit) in Guinea-Bissau in 2009 to that in 2010?
Make the answer very short. 0.91. What is the ratio of the Value added (current Local Currency Unit) of Marshall Islands in 2009 to that in 2010?
Offer a terse response. 0.77. What is the ratio of the Value added (current Local Currency Unit) in Antigua and Barbuda in 2009 to that in 2011?
Your answer should be compact. 0.83. What is the ratio of the Value added (current Local Currency Unit) of Guinea-Bissau in 2009 to that in 2011?
Make the answer very short. 0.74. What is the ratio of the Value added (current Local Currency Unit) of Marshall Islands in 2009 to that in 2011?
Provide a short and direct response. 0.71. What is the ratio of the Value added (current Local Currency Unit) in Antigua and Barbuda in 2009 to that in 2012?
Make the answer very short. 0.8. What is the ratio of the Value added (current Local Currency Unit) of Guinea-Bissau in 2009 to that in 2012?
Your answer should be compact. 0.75. What is the ratio of the Value added (current Local Currency Unit) of Marshall Islands in 2009 to that in 2012?
Make the answer very short. 0.47. What is the ratio of the Value added (current Local Currency Unit) of Antigua and Barbuda in 2009 to that in 2013?
Offer a terse response. 0.77. What is the ratio of the Value added (current Local Currency Unit) of Guinea-Bissau in 2009 to that in 2013?
Your response must be concise. 0.87. What is the ratio of the Value added (current Local Currency Unit) in Marshall Islands in 2009 to that in 2013?
Your response must be concise. 0.47. What is the ratio of the Value added (current Local Currency Unit) of Antigua and Barbuda in 2010 to that in 2011?
Your answer should be compact. 0.85. What is the ratio of the Value added (current Local Currency Unit) in Guinea-Bissau in 2010 to that in 2011?
Provide a short and direct response. 0.81. What is the ratio of the Value added (current Local Currency Unit) in Marshall Islands in 2010 to that in 2011?
Your response must be concise. 0.91. What is the ratio of the Value added (current Local Currency Unit) of Antigua and Barbuda in 2010 to that in 2012?
Give a very brief answer. 0.82. What is the ratio of the Value added (current Local Currency Unit) of Guinea-Bissau in 2010 to that in 2012?
Your response must be concise. 0.83. What is the ratio of the Value added (current Local Currency Unit) in Marshall Islands in 2010 to that in 2012?
Make the answer very short. 0.61. What is the ratio of the Value added (current Local Currency Unit) in Antigua and Barbuda in 2010 to that in 2013?
Provide a short and direct response. 0.79. What is the ratio of the Value added (current Local Currency Unit) in Guinea-Bissau in 2010 to that in 2013?
Ensure brevity in your answer.  0.96. What is the ratio of the Value added (current Local Currency Unit) of Marshall Islands in 2010 to that in 2013?
Ensure brevity in your answer.  0.61. What is the ratio of the Value added (current Local Currency Unit) in Antigua and Barbuda in 2011 to that in 2012?
Your answer should be very brief. 0.97. What is the ratio of the Value added (current Local Currency Unit) in Guinea-Bissau in 2011 to that in 2012?
Ensure brevity in your answer.  1.02. What is the ratio of the Value added (current Local Currency Unit) in Marshall Islands in 2011 to that in 2012?
Your response must be concise. 0.67. What is the ratio of the Value added (current Local Currency Unit) of Antigua and Barbuda in 2011 to that in 2013?
Provide a succinct answer. 0.92. What is the ratio of the Value added (current Local Currency Unit) of Guinea-Bissau in 2011 to that in 2013?
Ensure brevity in your answer.  1.19. What is the ratio of the Value added (current Local Currency Unit) of Marshall Islands in 2011 to that in 2013?
Offer a terse response. 0.66. What is the ratio of the Value added (current Local Currency Unit) of Antigua and Barbuda in 2012 to that in 2013?
Offer a very short reply. 0.96. What is the ratio of the Value added (current Local Currency Unit) of Guinea-Bissau in 2012 to that in 2013?
Offer a very short reply. 1.17. What is the ratio of the Value added (current Local Currency Unit) of Marshall Islands in 2012 to that in 2013?
Keep it short and to the point. 0.99. What is the difference between the highest and the second highest Value added (current Local Currency Unit) in Antigua and Barbuda?
Your answer should be compact. 2.83e+06. What is the difference between the highest and the second highest Value added (current Local Currency Unit) in Guinea-Bissau?
Offer a very short reply. 4.14e+09. What is the difference between the highest and the second highest Value added (current Local Currency Unit) in Marshall Islands?
Make the answer very short. 2.11e+05. What is the difference between the highest and the lowest Value added (current Local Currency Unit) in Antigua and Barbuda?
Keep it short and to the point. 1.49e+07. What is the difference between the highest and the lowest Value added (current Local Currency Unit) in Guinea-Bissau?
Provide a succinct answer. 1.02e+11. What is the difference between the highest and the lowest Value added (current Local Currency Unit) in Marshall Islands?
Your answer should be compact. 2.76e+07. 